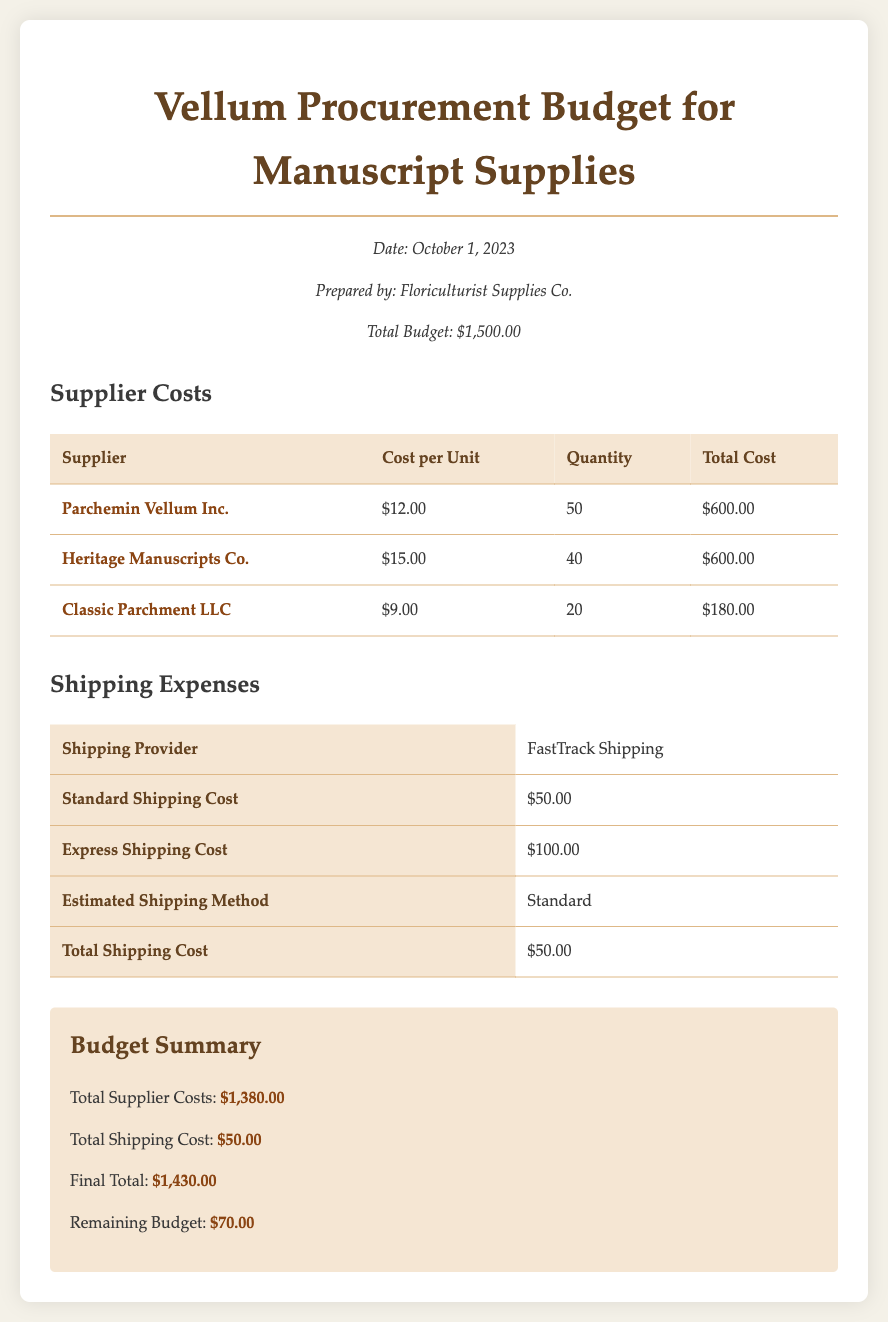What is the total budget? The total budget is provided at the beginning of the document as $1,500.00.
Answer: $1,500.00 Who is the first supplier listed? The first supplier listed in the Supplier Costs table is Parchemin Vellum Inc.
Answer: Parchemin Vellum Inc What is the cost per unit for Classic Parchment LLC? The document states the cost per unit for Classic Parchment LLC is $9.00.
Answer: $9.00 What is the total cost for Heritage Manuscripts Co.? The total cost for Heritage Manuscripts Co. is calculated and shown as $600.00.
Answer: $600.00 What is the estimated shipping method mentioned in the document? The document specifies the estimated shipping method as Standard.
Answer: Standard What is the total supplier costs? The total supplier costs calculated in the Budget Summary section is $1,380.00.
Answer: $1,380.00 What is the final total amount including shipping? The final total amount including shipping is noted in the Budget Summary section as $1,430.00.
Answer: $1,430.00 What is the remaining budget after total expenses? The remaining budget is provided in the Budget Summary as $70.00.
Answer: $70.00 